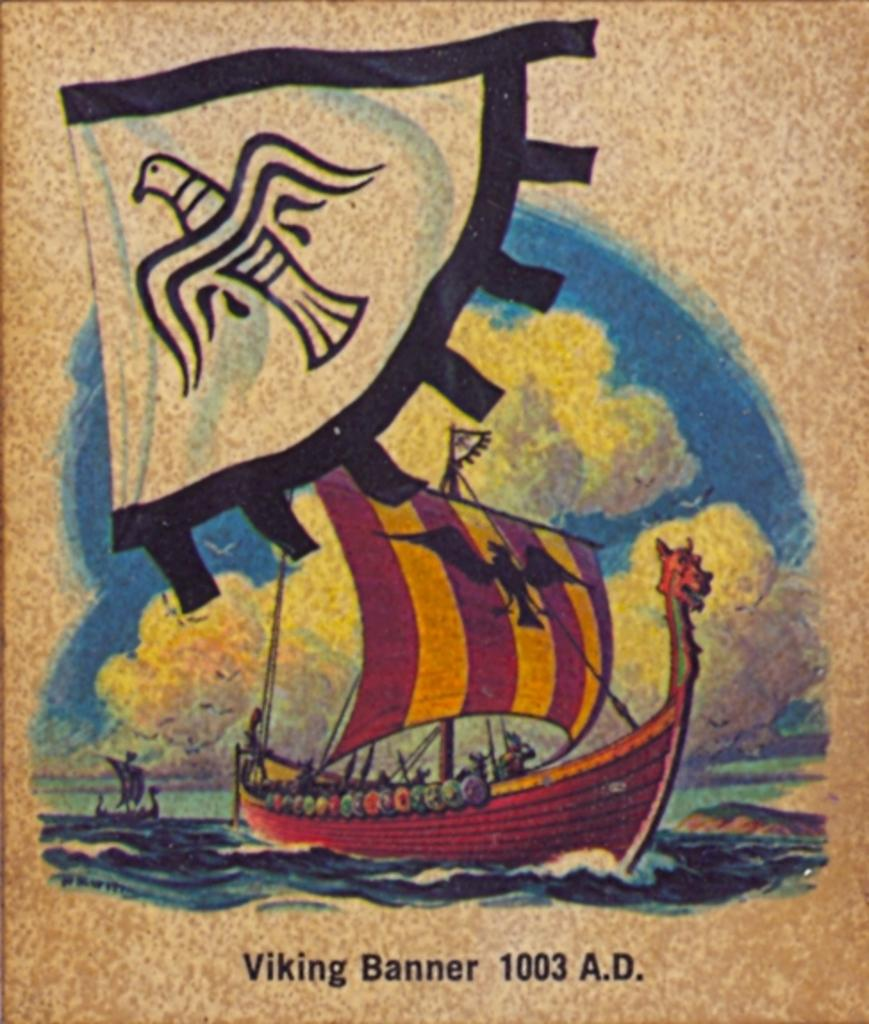<image>
Provide a brief description of the given image. A poster that says Viking Banner 1003 A.D. 